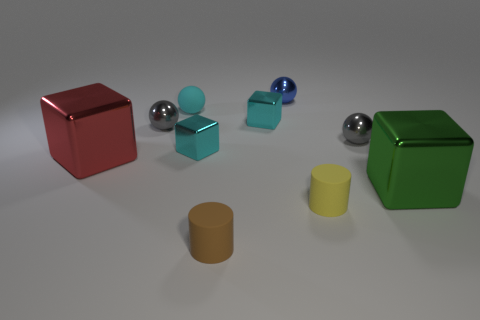Subtract all cyan balls. How many balls are left? 3 Subtract all red blocks. How many blocks are left? 3 Subtract all cylinders. How many objects are left? 8 Add 8 brown rubber cylinders. How many brown rubber cylinders are left? 9 Add 4 blue balls. How many blue balls exist? 5 Subtract 1 green blocks. How many objects are left? 9 Subtract 1 spheres. How many spheres are left? 3 Subtract all gray cylinders. Subtract all cyan spheres. How many cylinders are left? 2 Subtract all gray cubes. How many brown cylinders are left? 1 Subtract all tiny cyan things. Subtract all large shiny things. How many objects are left? 5 